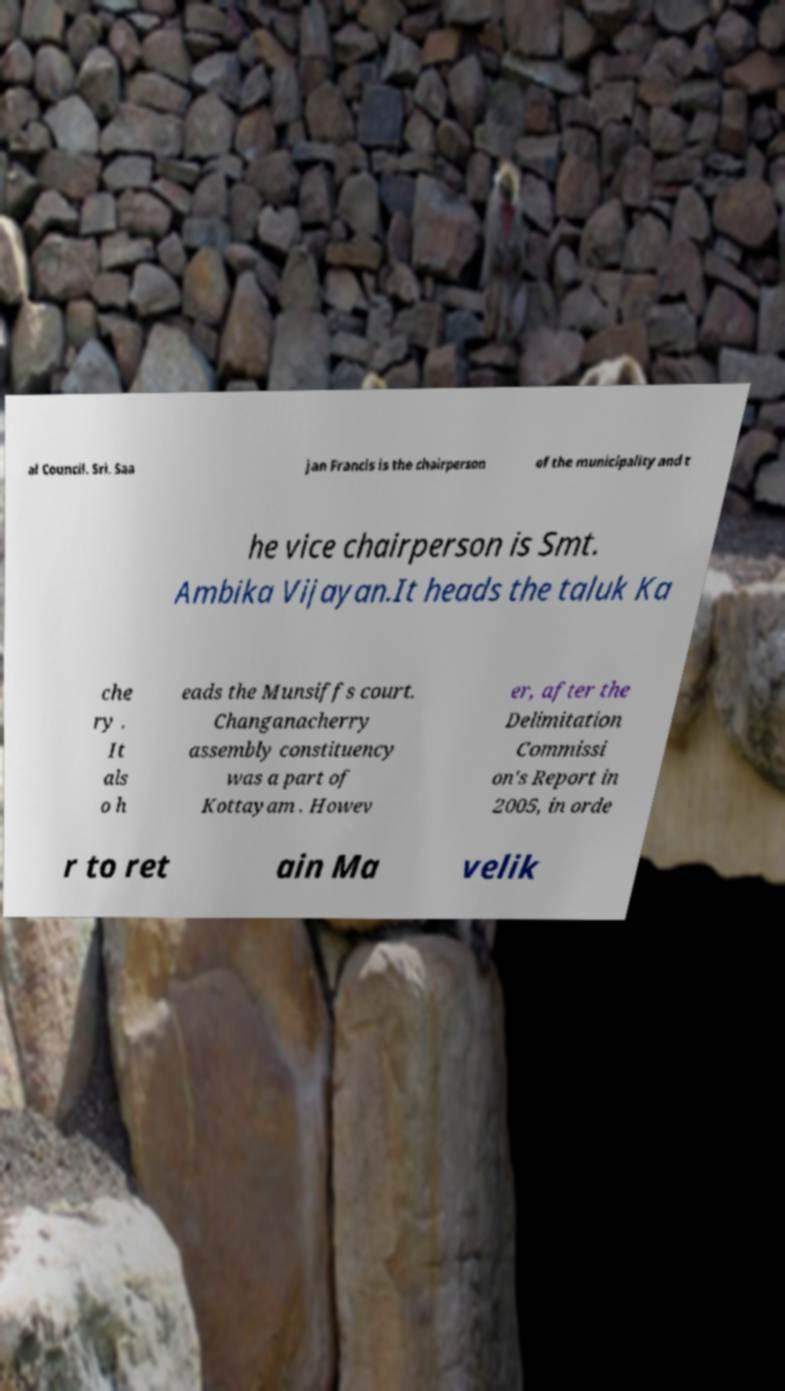Please read and relay the text visible in this image. What does it say? al Council. Sri. Saa jan Francis is the chairperson of the municipality and t he vice chairperson is Smt. Ambika Vijayan.It heads the taluk Ka che ry . It als o h eads the Munsiffs court. Changanacherry assembly constituency was a part of Kottayam . Howev er, after the Delimitation Commissi on's Report in 2005, in orde r to ret ain Ma velik 